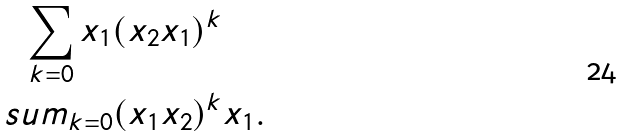<formula> <loc_0><loc_0><loc_500><loc_500>\sum _ { k = 0 } x _ { 1 } ( x _ { 2 } x _ { 1 } ) ^ { k } \quad \ \\ s u m _ { k = 0 } ( x _ { 1 } x _ { 2 } ) ^ { k } x _ { 1 } .</formula> 